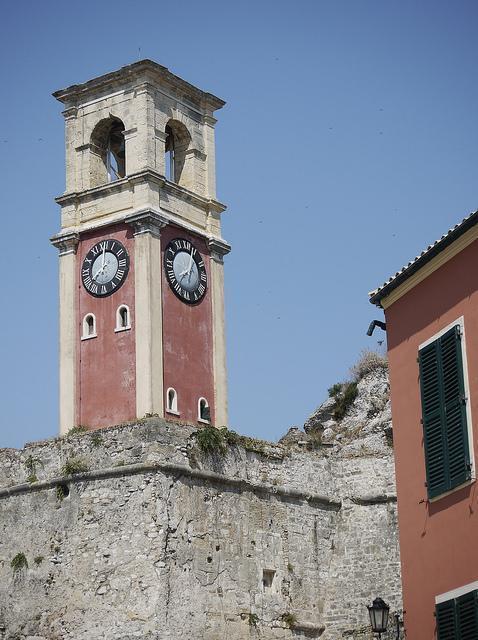How many clocks are in the photo?
Give a very brief answer. 2. How many clocks are visible?
Give a very brief answer. 2. 